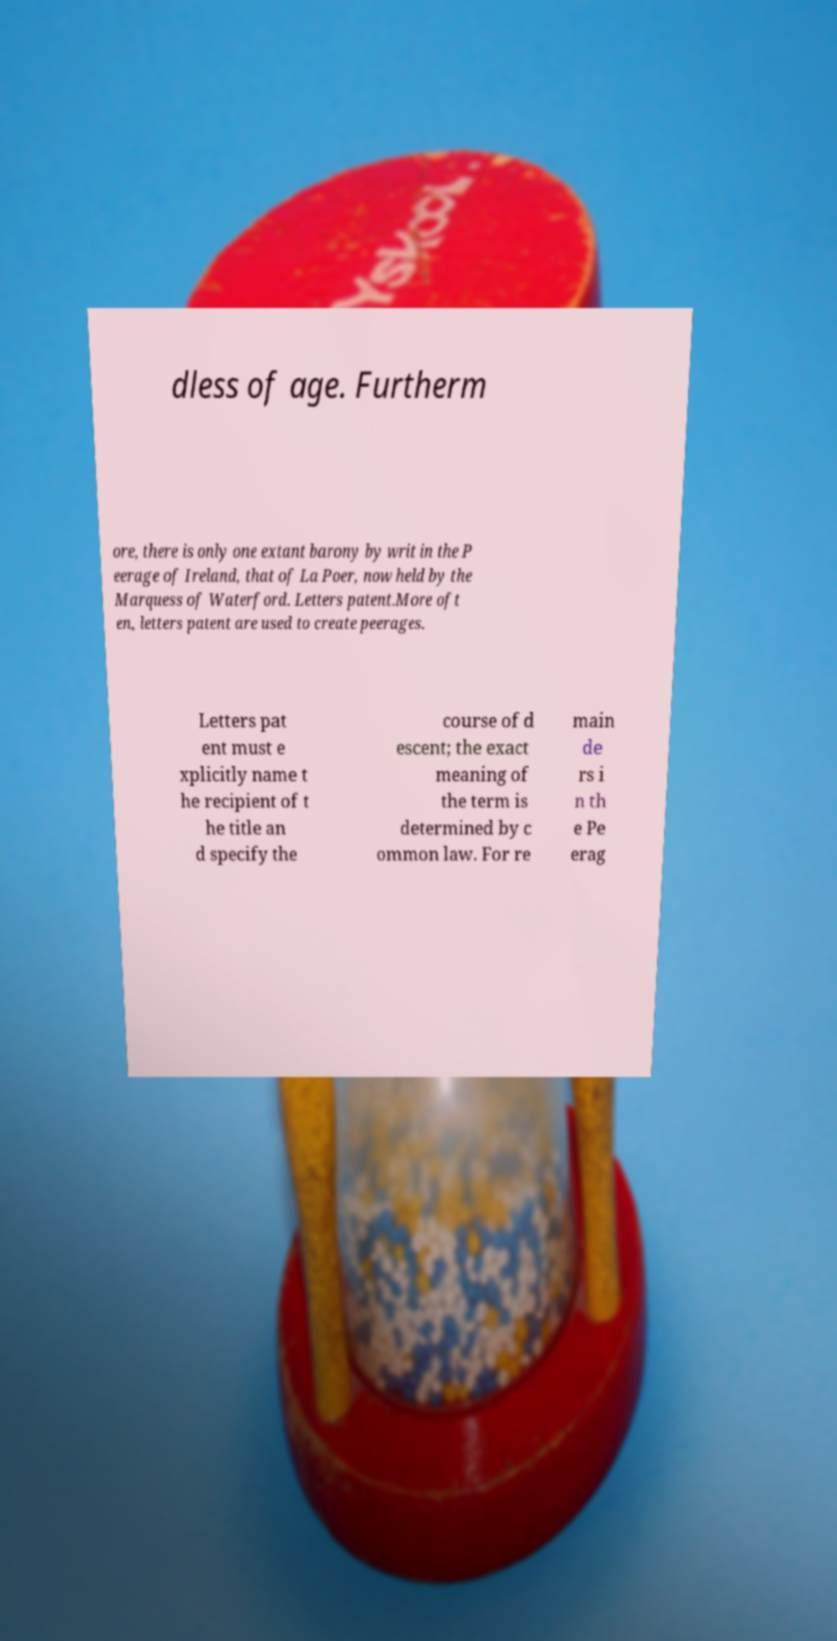Can you accurately transcribe the text from the provided image for me? dless of age. Furtherm ore, there is only one extant barony by writ in the P eerage of Ireland, that of La Poer, now held by the Marquess of Waterford. Letters patent.More oft en, letters patent are used to create peerages. Letters pat ent must e xplicitly name t he recipient of t he title an d specify the course of d escent; the exact meaning of the term is determined by c ommon law. For re main de rs i n th e Pe erag 